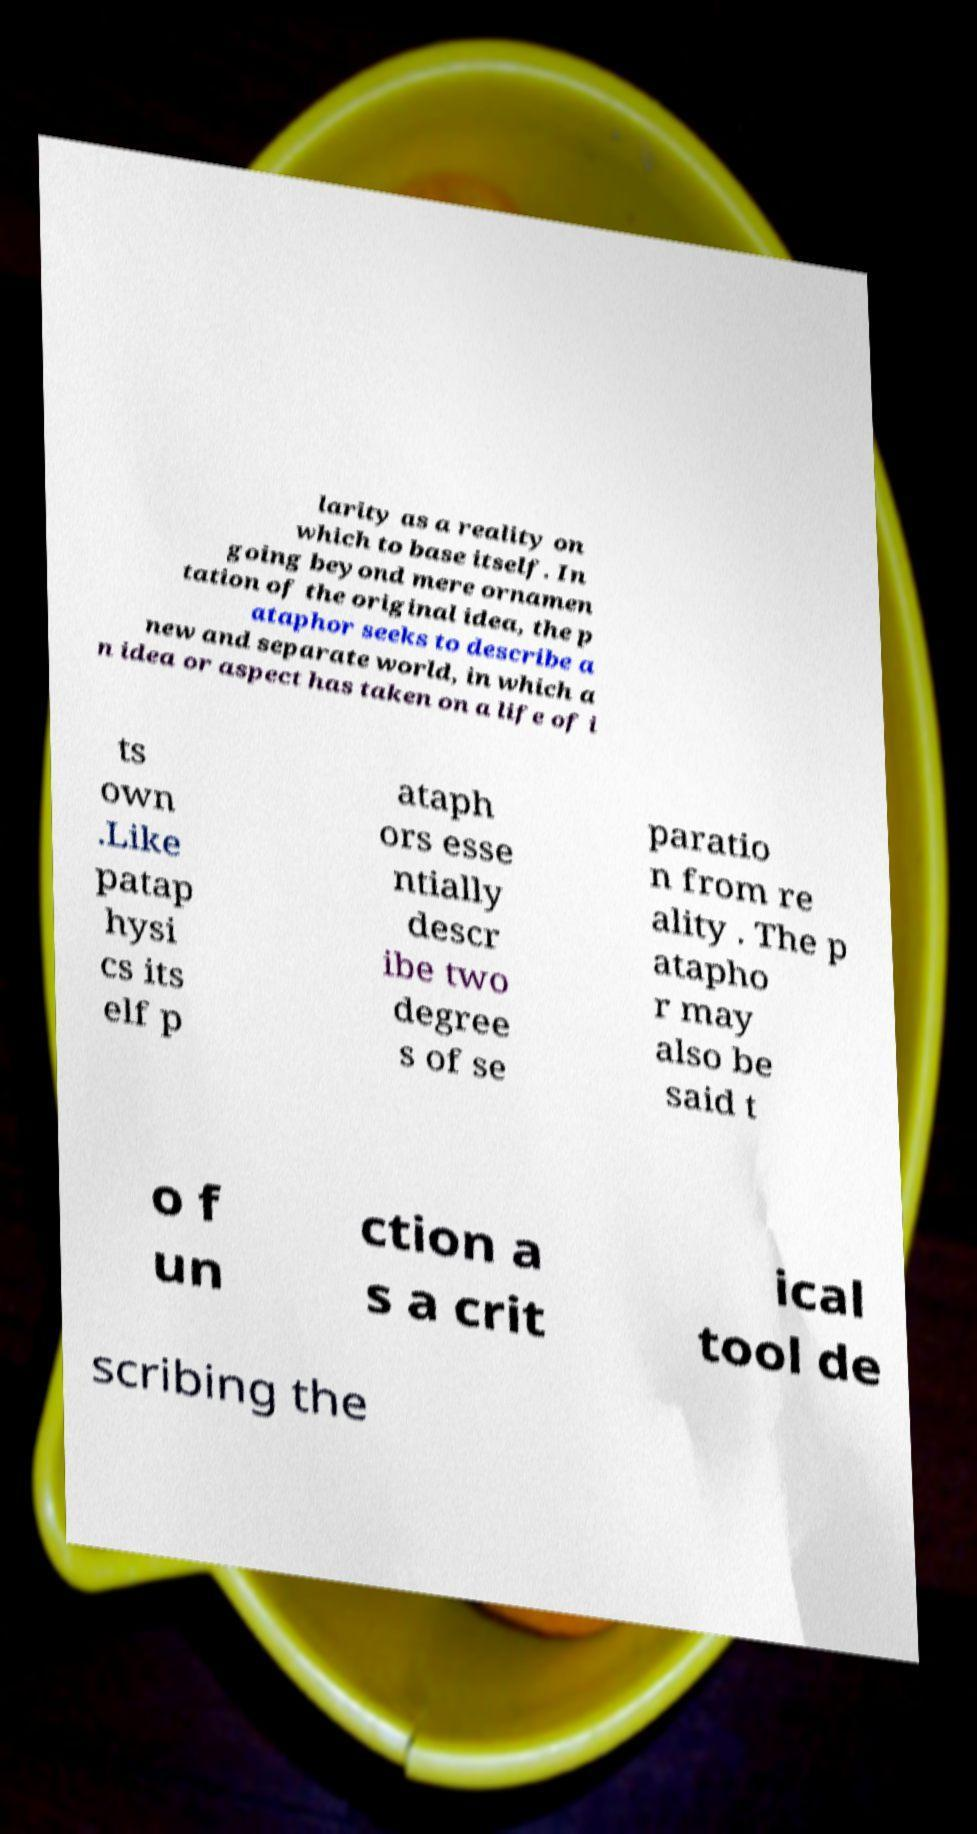Please identify and transcribe the text found in this image. larity as a reality on which to base itself. In going beyond mere ornamen tation of the original idea, the p ataphor seeks to describe a new and separate world, in which a n idea or aspect has taken on a life of i ts own .Like patap hysi cs its elf p ataph ors esse ntially descr ibe two degree s of se paratio n from re ality . The p atapho r may also be said t o f un ction a s a crit ical tool de scribing the 